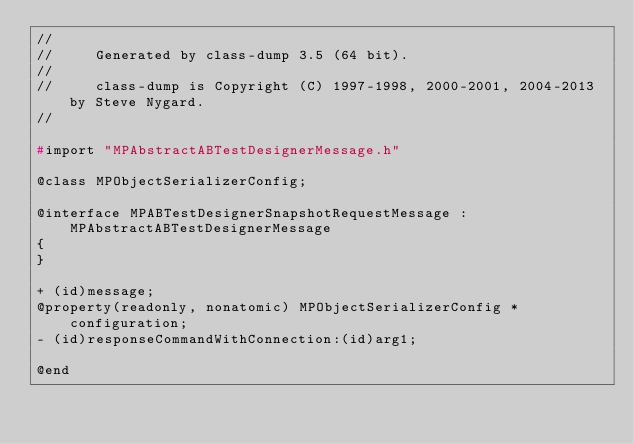Convert code to text. <code><loc_0><loc_0><loc_500><loc_500><_C_>//
//     Generated by class-dump 3.5 (64 bit).
//
//     class-dump is Copyright (C) 1997-1998, 2000-2001, 2004-2013 by Steve Nygard.
//

#import "MPAbstractABTestDesignerMessage.h"

@class MPObjectSerializerConfig;

@interface MPABTestDesignerSnapshotRequestMessage : MPAbstractABTestDesignerMessage
{
}

+ (id)message;
@property(readonly, nonatomic) MPObjectSerializerConfig *configuration;
- (id)responseCommandWithConnection:(id)arg1;

@end

</code> 